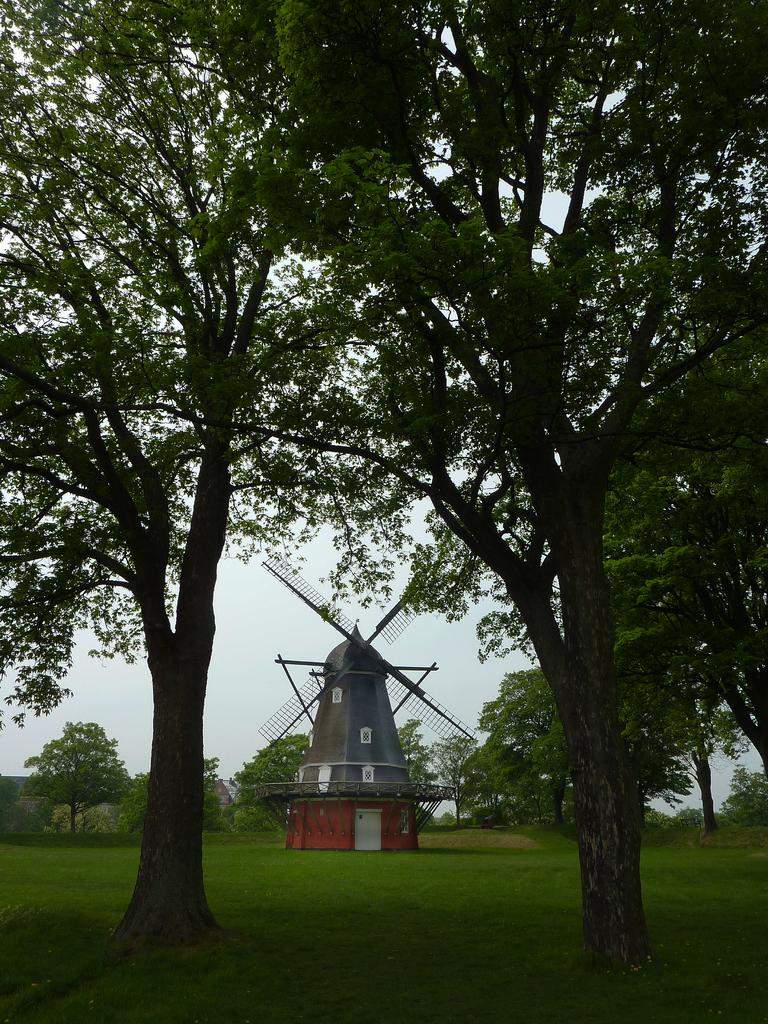What type of vegetation can be seen in the foreground of the image? There are trees and grassland in the foreground area of the image. What else can be seen in the foreground of the image besides vegetation? There are no other objects or structures visible in the foreground of the image. What is located in the background of the image? There are trees and a windmill in the background of the image. What is visible in the sky in the background of the image? The sky is visible in the background of the image. What type of boot is hanging from the windmill in the image? There is no boot present in the image; it features trees, grassland, and a windmill in the background. What word is written on the trees in the image? There are no words written on the trees in the image; it only shows natural elements such as trees, grassland, and a windmill. 